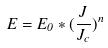<formula> <loc_0><loc_0><loc_500><loc_500>E = E _ { 0 } * ( \frac { J } { J _ { c } } ) ^ { n }</formula> 